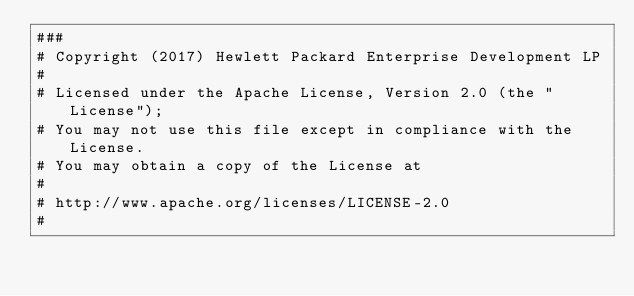Convert code to text. <code><loc_0><loc_0><loc_500><loc_500><_YAML_>###
# Copyright (2017) Hewlett Packard Enterprise Development LP
#
# Licensed under the Apache License, Version 2.0 (the "License");
# You may not use this file except in compliance with the License.
# You may obtain a copy of the License at
#
# http://www.apache.org/licenses/LICENSE-2.0
#</code> 